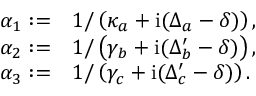Convert formula to latex. <formula><loc_0><loc_0><loc_500><loc_500>\begin{array} { r l } { \alpha _ { 1 } \colon = } & { 1 / \left ( \kappa _ { a } + i ( \Delta _ { a } - \delta ) \right ) , } \\ { \alpha _ { 2 } \colon = } & { 1 / \left ( \gamma _ { b } + i ( \Delta _ { b } ^ { \prime } - \delta ) \right ) , } \\ { \alpha _ { 3 } \colon = } & { 1 / \left ( \gamma _ { c } + i ( \Delta _ { c } ^ { \prime } - \delta ) \right ) . } \end{array}</formula> 